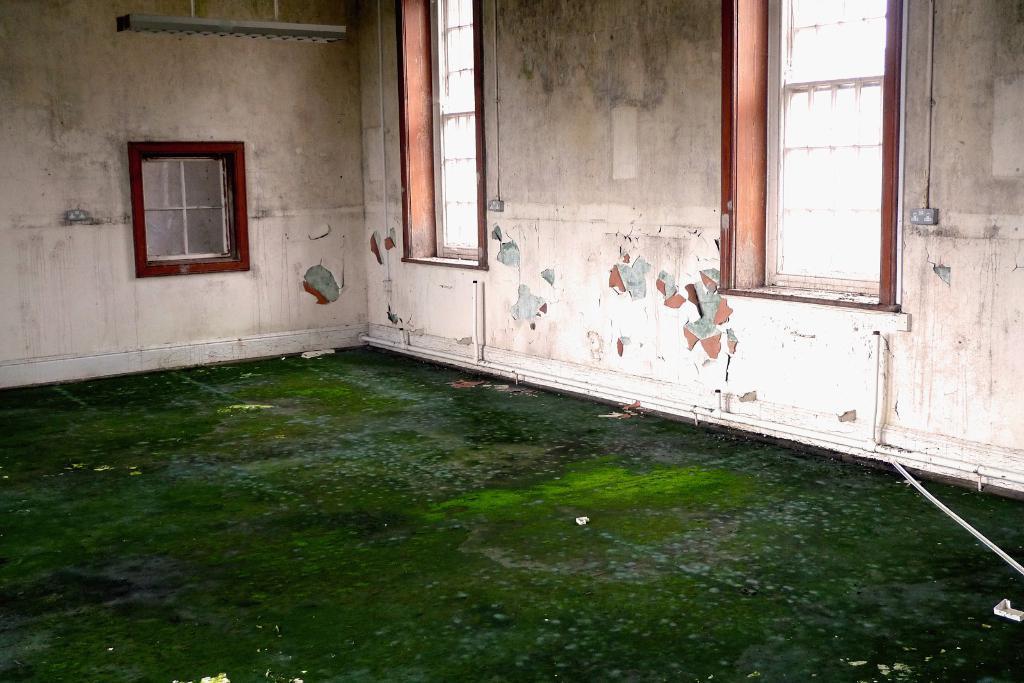Can you describe this image briefly? In this image I can see the room. And I can also see the windows to the wall. In the top I can see the road to the wall. 